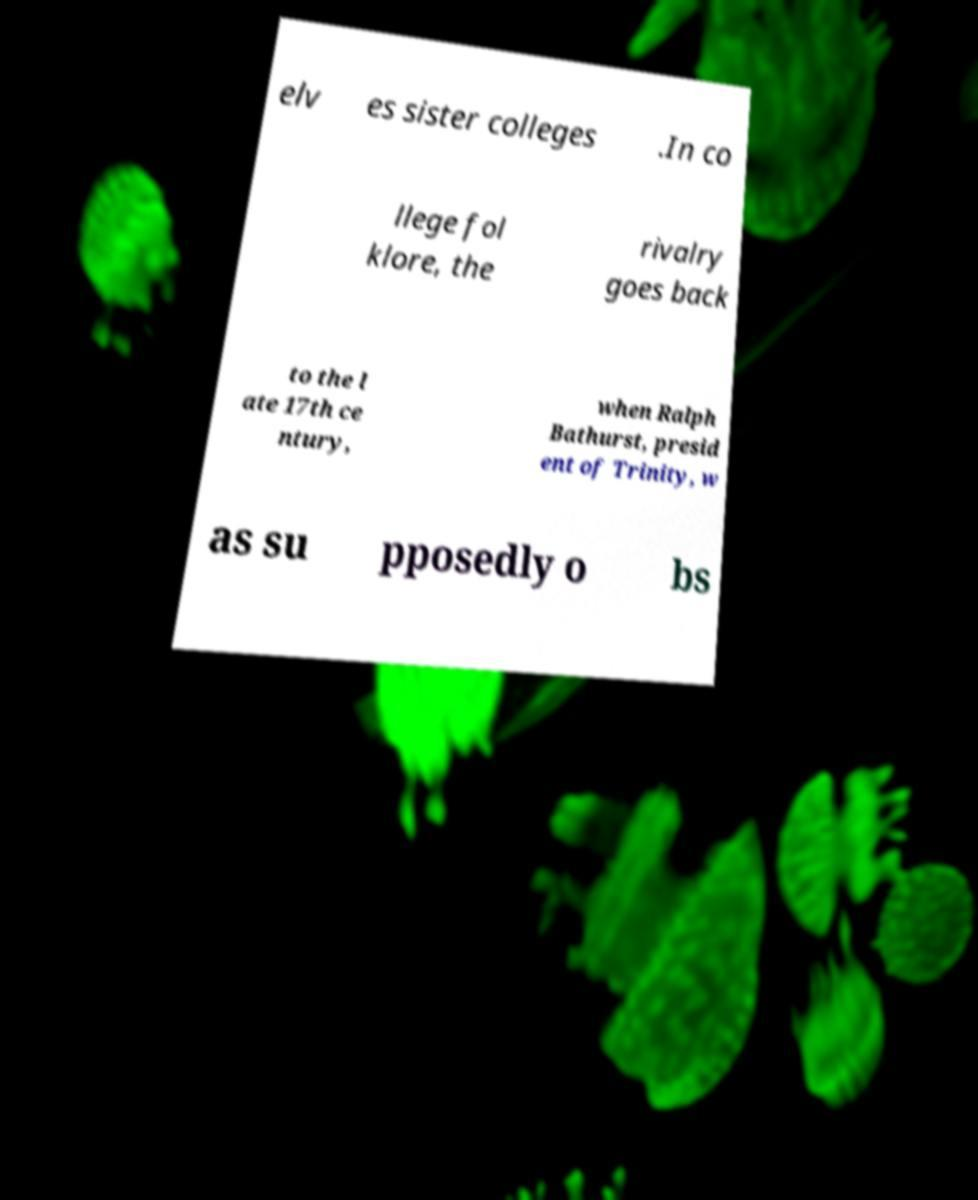Please identify and transcribe the text found in this image. elv es sister colleges .In co llege fol klore, the rivalry goes back to the l ate 17th ce ntury, when Ralph Bathurst, presid ent of Trinity, w as su pposedly o bs 